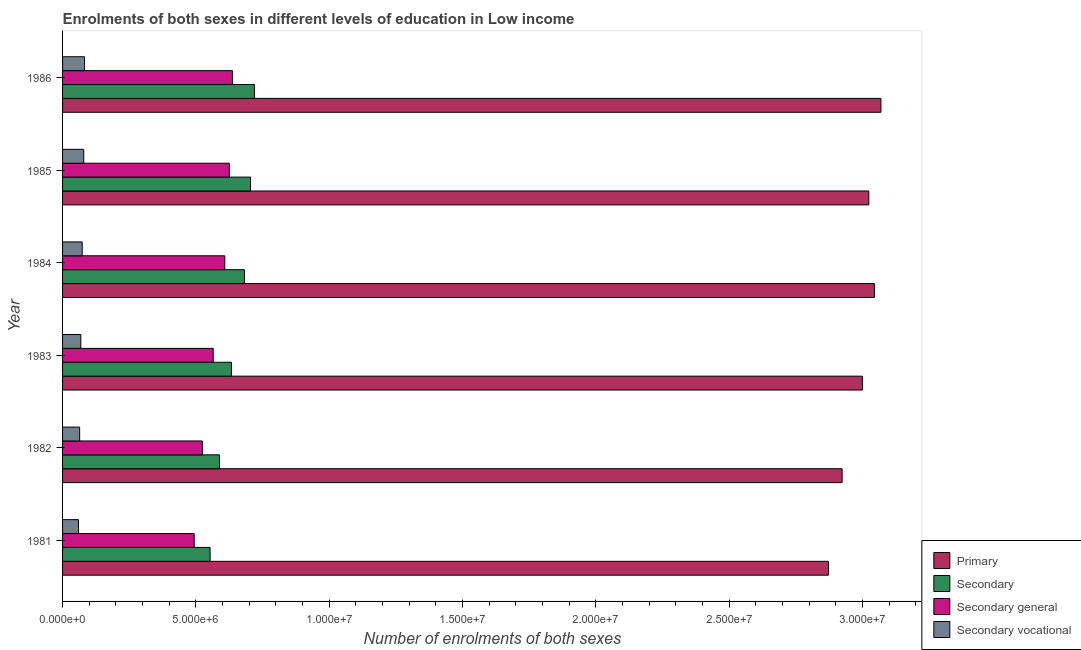How many bars are there on the 5th tick from the top?
Offer a terse response. 4. How many bars are there on the 1st tick from the bottom?
Your answer should be compact. 4. In how many cases, is the number of bars for a given year not equal to the number of legend labels?
Your answer should be very brief. 0. What is the number of enrolments in primary education in 1985?
Your response must be concise. 3.02e+07. Across all years, what is the maximum number of enrolments in secondary general education?
Provide a short and direct response. 6.37e+06. Across all years, what is the minimum number of enrolments in secondary vocational education?
Make the answer very short. 5.97e+05. In which year was the number of enrolments in secondary education maximum?
Provide a succinct answer. 1986. What is the total number of enrolments in secondary education in the graph?
Ensure brevity in your answer.  3.88e+07. What is the difference between the number of enrolments in secondary education in 1981 and that in 1983?
Ensure brevity in your answer.  -8.01e+05. What is the difference between the number of enrolments in secondary education in 1981 and the number of enrolments in secondary vocational education in 1985?
Your response must be concise. 4.74e+06. What is the average number of enrolments in primary education per year?
Your answer should be very brief. 2.99e+07. In the year 1982, what is the difference between the number of enrolments in secondary education and number of enrolments in secondary general education?
Your response must be concise. 6.41e+05. In how many years, is the number of enrolments in secondary general education greater than 16000000 ?
Ensure brevity in your answer.  0. Is the number of enrolments in secondary education in 1983 less than that in 1984?
Ensure brevity in your answer.  Yes. Is the difference between the number of enrolments in secondary vocational education in 1982 and 1986 greater than the difference between the number of enrolments in secondary education in 1982 and 1986?
Give a very brief answer. Yes. What is the difference between the highest and the second highest number of enrolments in secondary general education?
Give a very brief answer. 1.17e+05. What is the difference between the highest and the lowest number of enrolments in primary education?
Your answer should be very brief. 1.97e+06. Is the sum of the number of enrolments in secondary education in 1982 and 1984 greater than the maximum number of enrolments in primary education across all years?
Keep it short and to the point. No. Is it the case that in every year, the sum of the number of enrolments in secondary general education and number of enrolments in primary education is greater than the sum of number of enrolments in secondary education and number of enrolments in secondary vocational education?
Ensure brevity in your answer.  Yes. What does the 1st bar from the top in 1981 represents?
Give a very brief answer. Secondary vocational. What does the 1st bar from the bottom in 1986 represents?
Provide a succinct answer. Primary. How many years are there in the graph?
Your answer should be very brief. 6. Are the values on the major ticks of X-axis written in scientific E-notation?
Give a very brief answer. Yes. Where does the legend appear in the graph?
Make the answer very short. Bottom right. How many legend labels are there?
Give a very brief answer. 4. What is the title of the graph?
Your answer should be compact. Enrolments of both sexes in different levels of education in Low income. Does "Greece" appear as one of the legend labels in the graph?
Offer a terse response. No. What is the label or title of the X-axis?
Your response must be concise. Number of enrolments of both sexes. What is the label or title of the Y-axis?
Provide a succinct answer. Year. What is the Number of enrolments of both sexes in Primary in 1981?
Offer a terse response. 2.87e+07. What is the Number of enrolments of both sexes in Secondary in 1981?
Offer a terse response. 5.53e+06. What is the Number of enrolments of both sexes of Secondary general in 1981?
Make the answer very short. 4.94e+06. What is the Number of enrolments of both sexes in Secondary vocational in 1981?
Your response must be concise. 5.97e+05. What is the Number of enrolments of both sexes of Primary in 1982?
Your answer should be very brief. 2.92e+07. What is the Number of enrolments of both sexes in Secondary in 1982?
Keep it short and to the point. 5.88e+06. What is the Number of enrolments of both sexes of Secondary general in 1982?
Your answer should be compact. 5.24e+06. What is the Number of enrolments of both sexes in Secondary vocational in 1982?
Offer a terse response. 6.41e+05. What is the Number of enrolments of both sexes in Primary in 1983?
Provide a succinct answer. 3.00e+07. What is the Number of enrolments of both sexes in Secondary in 1983?
Offer a terse response. 6.33e+06. What is the Number of enrolments of both sexes of Secondary general in 1983?
Your answer should be very brief. 5.65e+06. What is the Number of enrolments of both sexes of Secondary vocational in 1983?
Give a very brief answer. 6.85e+05. What is the Number of enrolments of both sexes in Primary in 1984?
Offer a terse response. 3.04e+07. What is the Number of enrolments of both sexes in Secondary in 1984?
Offer a very short reply. 6.82e+06. What is the Number of enrolments of both sexes of Secondary general in 1984?
Your answer should be compact. 6.08e+06. What is the Number of enrolments of both sexes in Secondary vocational in 1984?
Your answer should be very brief. 7.36e+05. What is the Number of enrolments of both sexes in Primary in 1985?
Ensure brevity in your answer.  3.02e+07. What is the Number of enrolments of both sexes in Secondary in 1985?
Keep it short and to the point. 7.05e+06. What is the Number of enrolments of both sexes of Secondary general in 1985?
Your response must be concise. 6.25e+06. What is the Number of enrolments of both sexes of Secondary vocational in 1985?
Provide a short and direct response. 7.95e+05. What is the Number of enrolments of both sexes of Primary in 1986?
Your answer should be compact. 3.07e+07. What is the Number of enrolments of both sexes of Secondary in 1986?
Offer a terse response. 7.19e+06. What is the Number of enrolments of both sexes in Secondary general in 1986?
Your response must be concise. 6.37e+06. What is the Number of enrolments of both sexes in Secondary vocational in 1986?
Your answer should be very brief. 8.23e+05. Across all years, what is the maximum Number of enrolments of both sexes of Primary?
Your answer should be compact. 3.07e+07. Across all years, what is the maximum Number of enrolments of both sexes of Secondary?
Your answer should be compact. 7.19e+06. Across all years, what is the maximum Number of enrolments of both sexes in Secondary general?
Offer a terse response. 6.37e+06. Across all years, what is the maximum Number of enrolments of both sexes in Secondary vocational?
Your response must be concise. 8.23e+05. Across all years, what is the minimum Number of enrolments of both sexes of Primary?
Provide a succinct answer. 2.87e+07. Across all years, what is the minimum Number of enrolments of both sexes of Secondary?
Give a very brief answer. 5.53e+06. Across all years, what is the minimum Number of enrolments of both sexes of Secondary general?
Give a very brief answer. 4.94e+06. Across all years, what is the minimum Number of enrolments of both sexes of Secondary vocational?
Provide a succinct answer. 5.97e+05. What is the total Number of enrolments of both sexes in Primary in the graph?
Offer a terse response. 1.79e+08. What is the total Number of enrolments of both sexes of Secondary in the graph?
Provide a short and direct response. 3.88e+07. What is the total Number of enrolments of both sexes in Secondary general in the graph?
Your answer should be compact. 3.45e+07. What is the total Number of enrolments of both sexes in Secondary vocational in the graph?
Offer a terse response. 4.28e+06. What is the difference between the Number of enrolments of both sexes of Primary in 1981 and that in 1982?
Your answer should be very brief. -5.13e+05. What is the difference between the Number of enrolments of both sexes in Secondary in 1981 and that in 1982?
Your response must be concise. -3.51e+05. What is the difference between the Number of enrolments of both sexes of Secondary general in 1981 and that in 1982?
Provide a succinct answer. -3.06e+05. What is the difference between the Number of enrolments of both sexes of Secondary vocational in 1981 and that in 1982?
Make the answer very short. -4.43e+04. What is the difference between the Number of enrolments of both sexes in Primary in 1981 and that in 1983?
Offer a terse response. -1.27e+06. What is the difference between the Number of enrolments of both sexes of Secondary in 1981 and that in 1983?
Give a very brief answer. -8.01e+05. What is the difference between the Number of enrolments of both sexes in Secondary general in 1981 and that in 1983?
Make the answer very short. -7.13e+05. What is the difference between the Number of enrolments of both sexes of Secondary vocational in 1981 and that in 1983?
Provide a succinct answer. -8.82e+04. What is the difference between the Number of enrolments of both sexes in Primary in 1981 and that in 1984?
Keep it short and to the point. -1.72e+06. What is the difference between the Number of enrolments of both sexes in Secondary in 1981 and that in 1984?
Provide a short and direct response. -1.29e+06. What is the difference between the Number of enrolments of both sexes of Secondary general in 1981 and that in 1984?
Give a very brief answer. -1.15e+06. What is the difference between the Number of enrolments of both sexes of Secondary vocational in 1981 and that in 1984?
Your response must be concise. -1.39e+05. What is the difference between the Number of enrolments of both sexes in Primary in 1981 and that in 1985?
Provide a short and direct response. -1.51e+06. What is the difference between the Number of enrolments of both sexes in Secondary in 1981 and that in 1985?
Keep it short and to the point. -1.52e+06. What is the difference between the Number of enrolments of both sexes in Secondary general in 1981 and that in 1985?
Ensure brevity in your answer.  -1.32e+06. What is the difference between the Number of enrolments of both sexes in Secondary vocational in 1981 and that in 1985?
Make the answer very short. -1.98e+05. What is the difference between the Number of enrolments of both sexes of Primary in 1981 and that in 1986?
Offer a terse response. -1.97e+06. What is the difference between the Number of enrolments of both sexes of Secondary in 1981 and that in 1986?
Provide a short and direct response. -1.66e+06. What is the difference between the Number of enrolments of both sexes in Secondary general in 1981 and that in 1986?
Make the answer very short. -1.44e+06. What is the difference between the Number of enrolments of both sexes in Secondary vocational in 1981 and that in 1986?
Keep it short and to the point. -2.26e+05. What is the difference between the Number of enrolments of both sexes in Primary in 1982 and that in 1983?
Keep it short and to the point. -7.61e+05. What is the difference between the Number of enrolments of both sexes in Secondary in 1982 and that in 1983?
Keep it short and to the point. -4.50e+05. What is the difference between the Number of enrolments of both sexes of Secondary general in 1982 and that in 1983?
Make the answer very short. -4.06e+05. What is the difference between the Number of enrolments of both sexes of Secondary vocational in 1982 and that in 1983?
Your response must be concise. -4.39e+04. What is the difference between the Number of enrolments of both sexes in Primary in 1982 and that in 1984?
Give a very brief answer. -1.21e+06. What is the difference between the Number of enrolments of both sexes of Secondary in 1982 and that in 1984?
Keep it short and to the point. -9.36e+05. What is the difference between the Number of enrolments of both sexes of Secondary general in 1982 and that in 1984?
Provide a short and direct response. -8.41e+05. What is the difference between the Number of enrolments of both sexes in Secondary vocational in 1982 and that in 1984?
Give a very brief answer. -9.48e+04. What is the difference between the Number of enrolments of both sexes in Primary in 1982 and that in 1985?
Your answer should be compact. -1.00e+06. What is the difference between the Number of enrolments of both sexes in Secondary in 1982 and that in 1985?
Make the answer very short. -1.17e+06. What is the difference between the Number of enrolments of both sexes of Secondary general in 1982 and that in 1985?
Your answer should be compact. -1.01e+06. What is the difference between the Number of enrolments of both sexes of Secondary vocational in 1982 and that in 1985?
Keep it short and to the point. -1.54e+05. What is the difference between the Number of enrolments of both sexes of Primary in 1982 and that in 1986?
Offer a very short reply. -1.45e+06. What is the difference between the Number of enrolments of both sexes in Secondary in 1982 and that in 1986?
Provide a short and direct response. -1.31e+06. What is the difference between the Number of enrolments of both sexes of Secondary general in 1982 and that in 1986?
Ensure brevity in your answer.  -1.13e+06. What is the difference between the Number of enrolments of both sexes of Secondary vocational in 1982 and that in 1986?
Give a very brief answer. -1.82e+05. What is the difference between the Number of enrolments of both sexes in Primary in 1983 and that in 1984?
Your answer should be compact. -4.49e+05. What is the difference between the Number of enrolments of both sexes in Secondary in 1983 and that in 1984?
Ensure brevity in your answer.  -4.85e+05. What is the difference between the Number of enrolments of both sexes of Secondary general in 1983 and that in 1984?
Offer a very short reply. -4.35e+05. What is the difference between the Number of enrolments of both sexes of Secondary vocational in 1983 and that in 1984?
Give a very brief answer. -5.09e+04. What is the difference between the Number of enrolments of both sexes in Primary in 1983 and that in 1985?
Your response must be concise. -2.40e+05. What is the difference between the Number of enrolments of both sexes of Secondary in 1983 and that in 1985?
Your response must be concise. -7.15e+05. What is the difference between the Number of enrolments of both sexes in Secondary general in 1983 and that in 1985?
Make the answer very short. -6.06e+05. What is the difference between the Number of enrolments of both sexes in Secondary vocational in 1983 and that in 1985?
Offer a very short reply. -1.10e+05. What is the difference between the Number of enrolments of both sexes of Primary in 1983 and that in 1986?
Ensure brevity in your answer.  -6.93e+05. What is the difference between the Number of enrolments of both sexes in Secondary in 1983 and that in 1986?
Give a very brief answer. -8.61e+05. What is the difference between the Number of enrolments of both sexes in Secondary general in 1983 and that in 1986?
Give a very brief answer. -7.23e+05. What is the difference between the Number of enrolments of both sexes in Secondary vocational in 1983 and that in 1986?
Give a very brief answer. -1.38e+05. What is the difference between the Number of enrolments of both sexes in Primary in 1984 and that in 1985?
Provide a succinct answer. 2.09e+05. What is the difference between the Number of enrolments of both sexes in Secondary in 1984 and that in 1985?
Give a very brief answer. -2.30e+05. What is the difference between the Number of enrolments of both sexes in Secondary general in 1984 and that in 1985?
Offer a terse response. -1.71e+05. What is the difference between the Number of enrolments of both sexes in Secondary vocational in 1984 and that in 1985?
Offer a terse response. -5.89e+04. What is the difference between the Number of enrolments of both sexes in Primary in 1984 and that in 1986?
Your response must be concise. -2.44e+05. What is the difference between the Number of enrolments of both sexes of Secondary in 1984 and that in 1986?
Provide a succinct answer. -3.76e+05. What is the difference between the Number of enrolments of both sexes in Secondary general in 1984 and that in 1986?
Ensure brevity in your answer.  -2.88e+05. What is the difference between the Number of enrolments of both sexes of Secondary vocational in 1984 and that in 1986?
Make the answer very short. -8.72e+04. What is the difference between the Number of enrolments of both sexes of Primary in 1985 and that in 1986?
Provide a short and direct response. -4.53e+05. What is the difference between the Number of enrolments of both sexes of Secondary in 1985 and that in 1986?
Offer a very short reply. -1.46e+05. What is the difference between the Number of enrolments of both sexes in Secondary general in 1985 and that in 1986?
Give a very brief answer. -1.17e+05. What is the difference between the Number of enrolments of both sexes in Secondary vocational in 1985 and that in 1986?
Ensure brevity in your answer.  -2.82e+04. What is the difference between the Number of enrolments of both sexes of Primary in 1981 and the Number of enrolments of both sexes of Secondary in 1982?
Your answer should be compact. 2.28e+07. What is the difference between the Number of enrolments of both sexes in Primary in 1981 and the Number of enrolments of both sexes in Secondary general in 1982?
Provide a short and direct response. 2.35e+07. What is the difference between the Number of enrolments of both sexes in Primary in 1981 and the Number of enrolments of both sexes in Secondary vocational in 1982?
Provide a succinct answer. 2.81e+07. What is the difference between the Number of enrolments of both sexes of Secondary in 1981 and the Number of enrolments of both sexes of Secondary general in 1982?
Keep it short and to the point. 2.90e+05. What is the difference between the Number of enrolments of both sexes in Secondary in 1981 and the Number of enrolments of both sexes in Secondary vocational in 1982?
Your answer should be compact. 4.89e+06. What is the difference between the Number of enrolments of both sexes in Secondary general in 1981 and the Number of enrolments of both sexes in Secondary vocational in 1982?
Offer a very short reply. 4.30e+06. What is the difference between the Number of enrolments of both sexes in Primary in 1981 and the Number of enrolments of both sexes in Secondary in 1983?
Make the answer very short. 2.24e+07. What is the difference between the Number of enrolments of both sexes of Primary in 1981 and the Number of enrolments of both sexes of Secondary general in 1983?
Ensure brevity in your answer.  2.31e+07. What is the difference between the Number of enrolments of both sexes in Primary in 1981 and the Number of enrolments of both sexes in Secondary vocational in 1983?
Offer a very short reply. 2.80e+07. What is the difference between the Number of enrolments of both sexes in Secondary in 1981 and the Number of enrolments of both sexes in Secondary general in 1983?
Provide a succinct answer. -1.16e+05. What is the difference between the Number of enrolments of both sexes in Secondary in 1981 and the Number of enrolments of both sexes in Secondary vocational in 1983?
Offer a very short reply. 4.85e+06. What is the difference between the Number of enrolments of both sexes of Secondary general in 1981 and the Number of enrolments of both sexes of Secondary vocational in 1983?
Provide a succinct answer. 4.25e+06. What is the difference between the Number of enrolments of both sexes of Primary in 1981 and the Number of enrolments of both sexes of Secondary in 1984?
Offer a very short reply. 2.19e+07. What is the difference between the Number of enrolments of both sexes of Primary in 1981 and the Number of enrolments of both sexes of Secondary general in 1984?
Make the answer very short. 2.26e+07. What is the difference between the Number of enrolments of both sexes in Primary in 1981 and the Number of enrolments of both sexes in Secondary vocational in 1984?
Give a very brief answer. 2.80e+07. What is the difference between the Number of enrolments of both sexes of Secondary in 1981 and the Number of enrolments of both sexes of Secondary general in 1984?
Keep it short and to the point. -5.51e+05. What is the difference between the Number of enrolments of both sexes of Secondary in 1981 and the Number of enrolments of both sexes of Secondary vocational in 1984?
Keep it short and to the point. 4.80e+06. What is the difference between the Number of enrolments of both sexes of Secondary general in 1981 and the Number of enrolments of both sexes of Secondary vocational in 1984?
Your answer should be compact. 4.20e+06. What is the difference between the Number of enrolments of both sexes in Primary in 1981 and the Number of enrolments of both sexes in Secondary in 1985?
Offer a very short reply. 2.17e+07. What is the difference between the Number of enrolments of both sexes of Primary in 1981 and the Number of enrolments of both sexes of Secondary general in 1985?
Give a very brief answer. 2.25e+07. What is the difference between the Number of enrolments of both sexes in Primary in 1981 and the Number of enrolments of both sexes in Secondary vocational in 1985?
Your response must be concise. 2.79e+07. What is the difference between the Number of enrolments of both sexes of Secondary in 1981 and the Number of enrolments of both sexes of Secondary general in 1985?
Provide a short and direct response. -7.22e+05. What is the difference between the Number of enrolments of both sexes in Secondary in 1981 and the Number of enrolments of both sexes in Secondary vocational in 1985?
Offer a very short reply. 4.74e+06. What is the difference between the Number of enrolments of both sexes of Secondary general in 1981 and the Number of enrolments of both sexes of Secondary vocational in 1985?
Your answer should be compact. 4.14e+06. What is the difference between the Number of enrolments of both sexes in Primary in 1981 and the Number of enrolments of both sexes in Secondary in 1986?
Make the answer very short. 2.15e+07. What is the difference between the Number of enrolments of both sexes in Primary in 1981 and the Number of enrolments of both sexes in Secondary general in 1986?
Your response must be concise. 2.23e+07. What is the difference between the Number of enrolments of both sexes of Primary in 1981 and the Number of enrolments of both sexes of Secondary vocational in 1986?
Offer a terse response. 2.79e+07. What is the difference between the Number of enrolments of both sexes of Secondary in 1981 and the Number of enrolments of both sexes of Secondary general in 1986?
Offer a terse response. -8.39e+05. What is the difference between the Number of enrolments of both sexes of Secondary in 1981 and the Number of enrolments of both sexes of Secondary vocational in 1986?
Provide a short and direct response. 4.71e+06. What is the difference between the Number of enrolments of both sexes of Secondary general in 1981 and the Number of enrolments of both sexes of Secondary vocational in 1986?
Your answer should be compact. 4.11e+06. What is the difference between the Number of enrolments of both sexes in Primary in 1982 and the Number of enrolments of both sexes in Secondary in 1983?
Your answer should be compact. 2.29e+07. What is the difference between the Number of enrolments of both sexes in Primary in 1982 and the Number of enrolments of both sexes in Secondary general in 1983?
Ensure brevity in your answer.  2.36e+07. What is the difference between the Number of enrolments of both sexes of Primary in 1982 and the Number of enrolments of both sexes of Secondary vocational in 1983?
Keep it short and to the point. 2.86e+07. What is the difference between the Number of enrolments of both sexes in Secondary in 1982 and the Number of enrolments of both sexes in Secondary general in 1983?
Keep it short and to the point. 2.34e+05. What is the difference between the Number of enrolments of both sexes in Secondary in 1982 and the Number of enrolments of both sexes in Secondary vocational in 1983?
Offer a very short reply. 5.20e+06. What is the difference between the Number of enrolments of both sexes in Secondary general in 1982 and the Number of enrolments of both sexes in Secondary vocational in 1983?
Keep it short and to the point. 4.56e+06. What is the difference between the Number of enrolments of both sexes in Primary in 1982 and the Number of enrolments of both sexes in Secondary in 1984?
Provide a succinct answer. 2.24e+07. What is the difference between the Number of enrolments of both sexes of Primary in 1982 and the Number of enrolments of both sexes of Secondary general in 1984?
Give a very brief answer. 2.32e+07. What is the difference between the Number of enrolments of both sexes of Primary in 1982 and the Number of enrolments of both sexes of Secondary vocational in 1984?
Your response must be concise. 2.85e+07. What is the difference between the Number of enrolments of both sexes in Secondary in 1982 and the Number of enrolments of both sexes in Secondary general in 1984?
Keep it short and to the point. -2.00e+05. What is the difference between the Number of enrolments of both sexes in Secondary in 1982 and the Number of enrolments of both sexes in Secondary vocational in 1984?
Your answer should be very brief. 5.15e+06. What is the difference between the Number of enrolments of both sexes in Secondary general in 1982 and the Number of enrolments of both sexes in Secondary vocational in 1984?
Ensure brevity in your answer.  4.51e+06. What is the difference between the Number of enrolments of both sexes of Primary in 1982 and the Number of enrolments of both sexes of Secondary in 1985?
Give a very brief answer. 2.22e+07. What is the difference between the Number of enrolments of both sexes of Primary in 1982 and the Number of enrolments of both sexes of Secondary general in 1985?
Provide a succinct answer. 2.30e+07. What is the difference between the Number of enrolments of both sexes in Primary in 1982 and the Number of enrolments of both sexes in Secondary vocational in 1985?
Your answer should be very brief. 2.84e+07. What is the difference between the Number of enrolments of both sexes in Secondary in 1982 and the Number of enrolments of both sexes in Secondary general in 1985?
Ensure brevity in your answer.  -3.71e+05. What is the difference between the Number of enrolments of both sexes of Secondary in 1982 and the Number of enrolments of both sexes of Secondary vocational in 1985?
Provide a succinct answer. 5.09e+06. What is the difference between the Number of enrolments of both sexes in Secondary general in 1982 and the Number of enrolments of both sexes in Secondary vocational in 1985?
Offer a very short reply. 4.45e+06. What is the difference between the Number of enrolments of both sexes in Primary in 1982 and the Number of enrolments of both sexes in Secondary in 1986?
Provide a short and direct response. 2.20e+07. What is the difference between the Number of enrolments of both sexes in Primary in 1982 and the Number of enrolments of both sexes in Secondary general in 1986?
Make the answer very short. 2.29e+07. What is the difference between the Number of enrolments of both sexes of Primary in 1982 and the Number of enrolments of both sexes of Secondary vocational in 1986?
Your response must be concise. 2.84e+07. What is the difference between the Number of enrolments of both sexes in Secondary in 1982 and the Number of enrolments of both sexes in Secondary general in 1986?
Keep it short and to the point. -4.89e+05. What is the difference between the Number of enrolments of both sexes of Secondary in 1982 and the Number of enrolments of both sexes of Secondary vocational in 1986?
Your answer should be compact. 5.06e+06. What is the difference between the Number of enrolments of both sexes in Secondary general in 1982 and the Number of enrolments of both sexes in Secondary vocational in 1986?
Offer a terse response. 4.42e+06. What is the difference between the Number of enrolments of both sexes in Primary in 1983 and the Number of enrolments of both sexes in Secondary in 1984?
Keep it short and to the point. 2.32e+07. What is the difference between the Number of enrolments of both sexes in Primary in 1983 and the Number of enrolments of both sexes in Secondary general in 1984?
Offer a very short reply. 2.39e+07. What is the difference between the Number of enrolments of both sexes of Primary in 1983 and the Number of enrolments of both sexes of Secondary vocational in 1984?
Your answer should be compact. 2.93e+07. What is the difference between the Number of enrolments of both sexes of Secondary in 1983 and the Number of enrolments of both sexes of Secondary general in 1984?
Give a very brief answer. 2.50e+05. What is the difference between the Number of enrolments of both sexes of Secondary in 1983 and the Number of enrolments of both sexes of Secondary vocational in 1984?
Keep it short and to the point. 5.60e+06. What is the difference between the Number of enrolments of both sexes in Secondary general in 1983 and the Number of enrolments of both sexes in Secondary vocational in 1984?
Provide a succinct answer. 4.91e+06. What is the difference between the Number of enrolments of both sexes in Primary in 1983 and the Number of enrolments of both sexes in Secondary in 1985?
Ensure brevity in your answer.  2.29e+07. What is the difference between the Number of enrolments of both sexes of Primary in 1983 and the Number of enrolments of both sexes of Secondary general in 1985?
Give a very brief answer. 2.37e+07. What is the difference between the Number of enrolments of both sexes of Primary in 1983 and the Number of enrolments of both sexes of Secondary vocational in 1985?
Provide a short and direct response. 2.92e+07. What is the difference between the Number of enrolments of both sexes of Secondary in 1983 and the Number of enrolments of both sexes of Secondary general in 1985?
Provide a short and direct response. 7.92e+04. What is the difference between the Number of enrolments of both sexes in Secondary in 1983 and the Number of enrolments of both sexes in Secondary vocational in 1985?
Your answer should be very brief. 5.54e+06. What is the difference between the Number of enrolments of both sexes of Secondary general in 1983 and the Number of enrolments of both sexes of Secondary vocational in 1985?
Your response must be concise. 4.85e+06. What is the difference between the Number of enrolments of both sexes in Primary in 1983 and the Number of enrolments of both sexes in Secondary in 1986?
Ensure brevity in your answer.  2.28e+07. What is the difference between the Number of enrolments of both sexes in Primary in 1983 and the Number of enrolments of both sexes in Secondary general in 1986?
Ensure brevity in your answer.  2.36e+07. What is the difference between the Number of enrolments of both sexes of Primary in 1983 and the Number of enrolments of both sexes of Secondary vocational in 1986?
Offer a very short reply. 2.92e+07. What is the difference between the Number of enrolments of both sexes of Secondary in 1983 and the Number of enrolments of both sexes of Secondary general in 1986?
Give a very brief answer. -3.82e+04. What is the difference between the Number of enrolments of both sexes of Secondary in 1983 and the Number of enrolments of both sexes of Secondary vocational in 1986?
Your answer should be very brief. 5.51e+06. What is the difference between the Number of enrolments of both sexes in Secondary general in 1983 and the Number of enrolments of both sexes in Secondary vocational in 1986?
Make the answer very short. 4.83e+06. What is the difference between the Number of enrolments of both sexes in Primary in 1984 and the Number of enrolments of both sexes in Secondary in 1985?
Your answer should be very brief. 2.34e+07. What is the difference between the Number of enrolments of both sexes in Primary in 1984 and the Number of enrolments of both sexes in Secondary general in 1985?
Your response must be concise. 2.42e+07. What is the difference between the Number of enrolments of both sexes in Primary in 1984 and the Number of enrolments of both sexes in Secondary vocational in 1985?
Provide a succinct answer. 2.97e+07. What is the difference between the Number of enrolments of both sexes of Secondary in 1984 and the Number of enrolments of both sexes of Secondary general in 1985?
Ensure brevity in your answer.  5.65e+05. What is the difference between the Number of enrolments of both sexes of Secondary in 1984 and the Number of enrolments of both sexes of Secondary vocational in 1985?
Give a very brief answer. 6.02e+06. What is the difference between the Number of enrolments of both sexes of Secondary general in 1984 and the Number of enrolments of both sexes of Secondary vocational in 1985?
Ensure brevity in your answer.  5.29e+06. What is the difference between the Number of enrolments of both sexes of Primary in 1984 and the Number of enrolments of both sexes of Secondary in 1986?
Provide a short and direct response. 2.33e+07. What is the difference between the Number of enrolments of both sexes in Primary in 1984 and the Number of enrolments of both sexes in Secondary general in 1986?
Your answer should be compact. 2.41e+07. What is the difference between the Number of enrolments of both sexes of Primary in 1984 and the Number of enrolments of both sexes of Secondary vocational in 1986?
Ensure brevity in your answer.  2.96e+07. What is the difference between the Number of enrolments of both sexes of Secondary in 1984 and the Number of enrolments of both sexes of Secondary general in 1986?
Your answer should be compact. 4.47e+05. What is the difference between the Number of enrolments of both sexes of Secondary in 1984 and the Number of enrolments of both sexes of Secondary vocational in 1986?
Keep it short and to the point. 6.00e+06. What is the difference between the Number of enrolments of both sexes of Secondary general in 1984 and the Number of enrolments of both sexes of Secondary vocational in 1986?
Your response must be concise. 5.26e+06. What is the difference between the Number of enrolments of both sexes in Primary in 1985 and the Number of enrolments of both sexes in Secondary in 1986?
Keep it short and to the point. 2.30e+07. What is the difference between the Number of enrolments of both sexes of Primary in 1985 and the Number of enrolments of both sexes of Secondary general in 1986?
Provide a short and direct response. 2.39e+07. What is the difference between the Number of enrolments of both sexes in Primary in 1985 and the Number of enrolments of both sexes in Secondary vocational in 1986?
Keep it short and to the point. 2.94e+07. What is the difference between the Number of enrolments of both sexes of Secondary in 1985 and the Number of enrolments of both sexes of Secondary general in 1986?
Give a very brief answer. 6.77e+05. What is the difference between the Number of enrolments of both sexes of Secondary in 1985 and the Number of enrolments of both sexes of Secondary vocational in 1986?
Provide a short and direct response. 6.23e+06. What is the difference between the Number of enrolments of both sexes of Secondary general in 1985 and the Number of enrolments of both sexes of Secondary vocational in 1986?
Keep it short and to the point. 5.43e+06. What is the average Number of enrolments of both sexes in Primary per year?
Ensure brevity in your answer.  2.99e+07. What is the average Number of enrolments of both sexes of Secondary per year?
Your answer should be compact. 6.47e+06. What is the average Number of enrolments of both sexes in Secondary general per year?
Your response must be concise. 5.76e+06. What is the average Number of enrolments of both sexes in Secondary vocational per year?
Provide a succinct answer. 7.13e+05. In the year 1981, what is the difference between the Number of enrolments of both sexes in Primary and Number of enrolments of both sexes in Secondary?
Your response must be concise. 2.32e+07. In the year 1981, what is the difference between the Number of enrolments of both sexes in Primary and Number of enrolments of both sexes in Secondary general?
Your answer should be compact. 2.38e+07. In the year 1981, what is the difference between the Number of enrolments of both sexes in Primary and Number of enrolments of both sexes in Secondary vocational?
Your response must be concise. 2.81e+07. In the year 1981, what is the difference between the Number of enrolments of both sexes of Secondary and Number of enrolments of both sexes of Secondary general?
Provide a short and direct response. 5.97e+05. In the year 1981, what is the difference between the Number of enrolments of both sexes in Secondary and Number of enrolments of both sexes in Secondary vocational?
Ensure brevity in your answer.  4.94e+06. In the year 1981, what is the difference between the Number of enrolments of both sexes of Secondary general and Number of enrolments of both sexes of Secondary vocational?
Offer a terse response. 4.34e+06. In the year 1982, what is the difference between the Number of enrolments of both sexes of Primary and Number of enrolments of both sexes of Secondary?
Ensure brevity in your answer.  2.34e+07. In the year 1982, what is the difference between the Number of enrolments of both sexes of Primary and Number of enrolments of both sexes of Secondary general?
Offer a very short reply. 2.40e+07. In the year 1982, what is the difference between the Number of enrolments of both sexes of Primary and Number of enrolments of both sexes of Secondary vocational?
Keep it short and to the point. 2.86e+07. In the year 1982, what is the difference between the Number of enrolments of both sexes in Secondary and Number of enrolments of both sexes in Secondary general?
Keep it short and to the point. 6.41e+05. In the year 1982, what is the difference between the Number of enrolments of both sexes of Secondary and Number of enrolments of both sexes of Secondary vocational?
Your answer should be compact. 5.24e+06. In the year 1982, what is the difference between the Number of enrolments of both sexes in Secondary general and Number of enrolments of both sexes in Secondary vocational?
Provide a succinct answer. 4.60e+06. In the year 1983, what is the difference between the Number of enrolments of both sexes of Primary and Number of enrolments of both sexes of Secondary?
Your answer should be very brief. 2.37e+07. In the year 1983, what is the difference between the Number of enrolments of both sexes of Primary and Number of enrolments of both sexes of Secondary general?
Provide a succinct answer. 2.43e+07. In the year 1983, what is the difference between the Number of enrolments of both sexes of Primary and Number of enrolments of both sexes of Secondary vocational?
Offer a terse response. 2.93e+07. In the year 1983, what is the difference between the Number of enrolments of both sexes of Secondary and Number of enrolments of both sexes of Secondary general?
Make the answer very short. 6.85e+05. In the year 1983, what is the difference between the Number of enrolments of both sexes of Secondary and Number of enrolments of both sexes of Secondary vocational?
Give a very brief answer. 5.65e+06. In the year 1983, what is the difference between the Number of enrolments of both sexes of Secondary general and Number of enrolments of both sexes of Secondary vocational?
Provide a short and direct response. 4.96e+06. In the year 1984, what is the difference between the Number of enrolments of both sexes of Primary and Number of enrolments of both sexes of Secondary?
Ensure brevity in your answer.  2.36e+07. In the year 1984, what is the difference between the Number of enrolments of both sexes of Primary and Number of enrolments of both sexes of Secondary general?
Offer a very short reply. 2.44e+07. In the year 1984, what is the difference between the Number of enrolments of both sexes of Primary and Number of enrolments of both sexes of Secondary vocational?
Offer a terse response. 2.97e+07. In the year 1984, what is the difference between the Number of enrolments of both sexes in Secondary and Number of enrolments of both sexes in Secondary general?
Offer a very short reply. 7.36e+05. In the year 1984, what is the difference between the Number of enrolments of both sexes in Secondary and Number of enrolments of both sexes in Secondary vocational?
Ensure brevity in your answer.  6.08e+06. In the year 1984, what is the difference between the Number of enrolments of both sexes in Secondary general and Number of enrolments of both sexes in Secondary vocational?
Your response must be concise. 5.35e+06. In the year 1985, what is the difference between the Number of enrolments of both sexes of Primary and Number of enrolments of both sexes of Secondary?
Ensure brevity in your answer.  2.32e+07. In the year 1985, what is the difference between the Number of enrolments of both sexes in Primary and Number of enrolments of both sexes in Secondary general?
Your response must be concise. 2.40e+07. In the year 1985, what is the difference between the Number of enrolments of both sexes in Primary and Number of enrolments of both sexes in Secondary vocational?
Your answer should be very brief. 2.94e+07. In the year 1985, what is the difference between the Number of enrolments of both sexes in Secondary and Number of enrolments of both sexes in Secondary general?
Offer a terse response. 7.95e+05. In the year 1985, what is the difference between the Number of enrolments of both sexes in Secondary and Number of enrolments of both sexes in Secondary vocational?
Provide a succinct answer. 6.25e+06. In the year 1985, what is the difference between the Number of enrolments of both sexes in Secondary general and Number of enrolments of both sexes in Secondary vocational?
Give a very brief answer. 5.46e+06. In the year 1986, what is the difference between the Number of enrolments of both sexes in Primary and Number of enrolments of both sexes in Secondary?
Your answer should be very brief. 2.35e+07. In the year 1986, what is the difference between the Number of enrolments of both sexes in Primary and Number of enrolments of both sexes in Secondary general?
Your answer should be very brief. 2.43e+07. In the year 1986, what is the difference between the Number of enrolments of both sexes of Primary and Number of enrolments of both sexes of Secondary vocational?
Provide a succinct answer. 2.99e+07. In the year 1986, what is the difference between the Number of enrolments of both sexes in Secondary and Number of enrolments of both sexes in Secondary general?
Give a very brief answer. 8.23e+05. In the year 1986, what is the difference between the Number of enrolments of both sexes of Secondary and Number of enrolments of both sexes of Secondary vocational?
Keep it short and to the point. 6.37e+06. In the year 1986, what is the difference between the Number of enrolments of both sexes in Secondary general and Number of enrolments of both sexes in Secondary vocational?
Give a very brief answer. 5.55e+06. What is the ratio of the Number of enrolments of both sexes of Primary in 1981 to that in 1982?
Offer a very short reply. 0.98. What is the ratio of the Number of enrolments of both sexes in Secondary in 1981 to that in 1982?
Provide a succinct answer. 0.94. What is the ratio of the Number of enrolments of both sexes of Secondary general in 1981 to that in 1982?
Your response must be concise. 0.94. What is the ratio of the Number of enrolments of both sexes in Secondary vocational in 1981 to that in 1982?
Make the answer very short. 0.93. What is the ratio of the Number of enrolments of both sexes of Primary in 1981 to that in 1983?
Ensure brevity in your answer.  0.96. What is the ratio of the Number of enrolments of both sexes in Secondary in 1981 to that in 1983?
Your response must be concise. 0.87. What is the ratio of the Number of enrolments of both sexes of Secondary general in 1981 to that in 1983?
Your answer should be very brief. 0.87. What is the ratio of the Number of enrolments of both sexes in Secondary vocational in 1981 to that in 1983?
Your answer should be very brief. 0.87. What is the ratio of the Number of enrolments of both sexes in Primary in 1981 to that in 1984?
Give a very brief answer. 0.94. What is the ratio of the Number of enrolments of both sexes in Secondary in 1981 to that in 1984?
Offer a very short reply. 0.81. What is the ratio of the Number of enrolments of both sexes of Secondary general in 1981 to that in 1984?
Ensure brevity in your answer.  0.81. What is the ratio of the Number of enrolments of both sexes in Secondary vocational in 1981 to that in 1984?
Provide a short and direct response. 0.81. What is the ratio of the Number of enrolments of both sexes in Primary in 1981 to that in 1985?
Your answer should be very brief. 0.95. What is the ratio of the Number of enrolments of both sexes in Secondary in 1981 to that in 1985?
Make the answer very short. 0.78. What is the ratio of the Number of enrolments of both sexes of Secondary general in 1981 to that in 1985?
Make the answer very short. 0.79. What is the ratio of the Number of enrolments of both sexes in Secondary vocational in 1981 to that in 1985?
Your answer should be very brief. 0.75. What is the ratio of the Number of enrolments of both sexes of Primary in 1981 to that in 1986?
Offer a terse response. 0.94. What is the ratio of the Number of enrolments of both sexes of Secondary in 1981 to that in 1986?
Give a very brief answer. 0.77. What is the ratio of the Number of enrolments of both sexes in Secondary general in 1981 to that in 1986?
Your answer should be very brief. 0.77. What is the ratio of the Number of enrolments of both sexes in Secondary vocational in 1981 to that in 1986?
Provide a short and direct response. 0.72. What is the ratio of the Number of enrolments of both sexes in Primary in 1982 to that in 1983?
Your response must be concise. 0.97. What is the ratio of the Number of enrolments of both sexes of Secondary in 1982 to that in 1983?
Make the answer very short. 0.93. What is the ratio of the Number of enrolments of both sexes in Secondary general in 1982 to that in 1983?
Offer a very short reply. 0.93. What is the ratio of the Number of enrolments of both sexes of Secondary vocational in 1982 to that in 1983?
Provide a succinct answer. 0.94. What is the ratio of the Number of enrolments of both sexes of Primary in 1982 to that in 1984?
Provide a short and direct response. 0.96. What is the ratio of the Number of enrolments of both sexes in Secondary in 1982 to that in 1984?
Your answer should be compact. 0.86. What is the ratio of the Number of enrolments of both sexes of Secondary general in 1982 to that in 1984?
Make the answer very short. 0.86. What is the ratio of the Number of enrolments of both sexes in Secondary vocational in 1982 to that in 1984?
Offer a very short reply. 0.87. What is the ratio of the Number of enrolments of both sexes in Primary in 1982 to that in 1985?
Keep it short and to the point. 0.97. What is the ratio of the Number of enrolments of both sexes in Secondary in 1982 to that in 1985?
Keep it short and to the point. 0.83. What is the ratio of the Number of enrolments of both sexes in Secondary general in 1982 to that in 1985?
Your answer should be compact. 0.84. What is the ratio of the Number of enrolments of both sexes of Secondary vocational in 1982 to that in 1985?
Your answer should be compact. 0.81. What is the ratio of the Number of enrolments of both sexes in Primary in 1982 to that in 1986?
Make the answer very short. 0.95. What is the ratio of the Number of enrolments of both sexes in Secondary in 1982 to that in 1986?
Your answer should be compact. 0.82. What is the ratio of the Number of enrolments of both sexes of Secondary general in 1982 to that in 1986?
Your answer should be compact. 0.82. What is the ratio of the Number of enrolments of both sexes of Secondary vocational in 1982 to that in 1986?
Make the answer very short. 0.78. What is the ratio of the Number of enrolments of both sexes in Primary in 1983 to that in 1984?
Your answer should be very brief. 0.99. What is the ratio of the Number of enrolments of both sexes in Secondary in 1983 to that in 1984?
Ensure brevity in your answer.  0.93. What is the ratio of the Number of enrolments of both sexes of Secondary vocational in 1983 to that in 1984?
Ensure brevity in your answer.  0.93. What is the ratio of the Number of enrolments of both sexes of Primary in 1983 to that in 1985?
Provide a short and direct response. 0.99. What is the ratio of the Number of enrolments of both sexes in Secondary in 1983 to that in 1985?
Provide a short and direct response. 0.9. What is the ratio of the Number of enrolments of both sexes in Secondary general in 1983 to that in 1985?
Ensure brevity in your answer.  0.9. What is the ratio of the Number of enrolments of both sexes in Secondary vocational in 1983 to that in 1985?
Your answer should be compact. 0.86. What is the ratio of the Number of enrolments of both sexes of Primary in 1983 to that in 1986?
Provide a succinct answer. 0.98. What is the ratio of the Number of enrolments of both sexes in Secondary in 1983 to that in 1986?
Keep it short and to the point. 0.88. What is the ratio of the Number of enrolments of both sexes of Secondary general in 1983 to that in 1986?
Your answer should be very brief. 0.89. What is the ratio of the Number of enrolments of both sexes in Secondary vocational in 1983 to that in 1986?
Provide a short and direct response. 0.83. What is the ratio of the Number of enrolments of both sexes in Secondary in 1984 to that in 1985?
Your answer should be very brief. 0.97. What is the ratio of the Number of enrolments of both sexes in Secondary general in 1984 to that in 1985?
Your response must be concise. 0.97. What is the ratio of the Number of enrolments of both sexes of Secondary vocational in 1984 to that in 1985?
Offer a terse response. 0.93. What is the ratio of the Number of enrolments of both sexes of Primary in 1984 to that in 1986?
Offer a very short reply. 0.99. What is the ratio of the Number of enrolments of both sexes of Secondary in 1984 to that in 1986?
Give a very brief answer. 0.95. What is the ratio of the Number of enrolments of both sexes of Secondary general in 1984 to that in 1986?
Provide a succinct answer. 0.95. What is the ratio of the Number of enrolments of both sexes in Secondary vocational in 1984 to that in 1986?
Offer a terse response. 0.89. What is the ratio of the Number of enrolments of both sexes of Primary in 1985 to that in 1986?
Provide a succinct answer. 0.99. What is the ratio of the Number of enrolments of both sexes in Secondary in 1985 to that in 1986?
Offer a terse response. 0.98. What is the ratio of the Number of enrolments of both sexes in Secondary general in 1985 to that in 1986?
Provide a short and direct response. 0.98. What is the ratio of the Number of enrolments of both sexes of Secondary vocational in 1985 to that in 1986?
Your response must be concise. 0.97. What is the difference between the highest and the second highest Number of enrolments of both sexes in Primary?
Offer a terse response. 2.44e+05. What is the difference between the highest and the second highest Number of enrolments of both sexes in Secondary?
Offer a terse response. 1.46e+05. What is the difference between the highest and the second highest Number of enrolments of both sexes in Secondary general?
Give a very brief answer. 1.17e+05. What is the difference between the highest and the second highest Number of enrolments of both sexes of Secondary vocational?
Your answer should be compact. 2.82e+04. What is the difference between the highest and the lowest Number of enrolments of both sexes in Primary?
Ensure brevity in your answer.  1.97e+06. What is the difference between the highest and the lowest Number of enrolments of both sexes in Secondary?
Keep it short and to the point. 1.66e+06. What is the difference between the highest and the lowest Number of enrolments of both sexes in Secondary general?
Give a very brief answer. 1.44e+06. What is the difference between the highest and the lowest Number of enrolments of both sexes in Secondary vocational?
Your answer should be compact. 2.26e+05. 